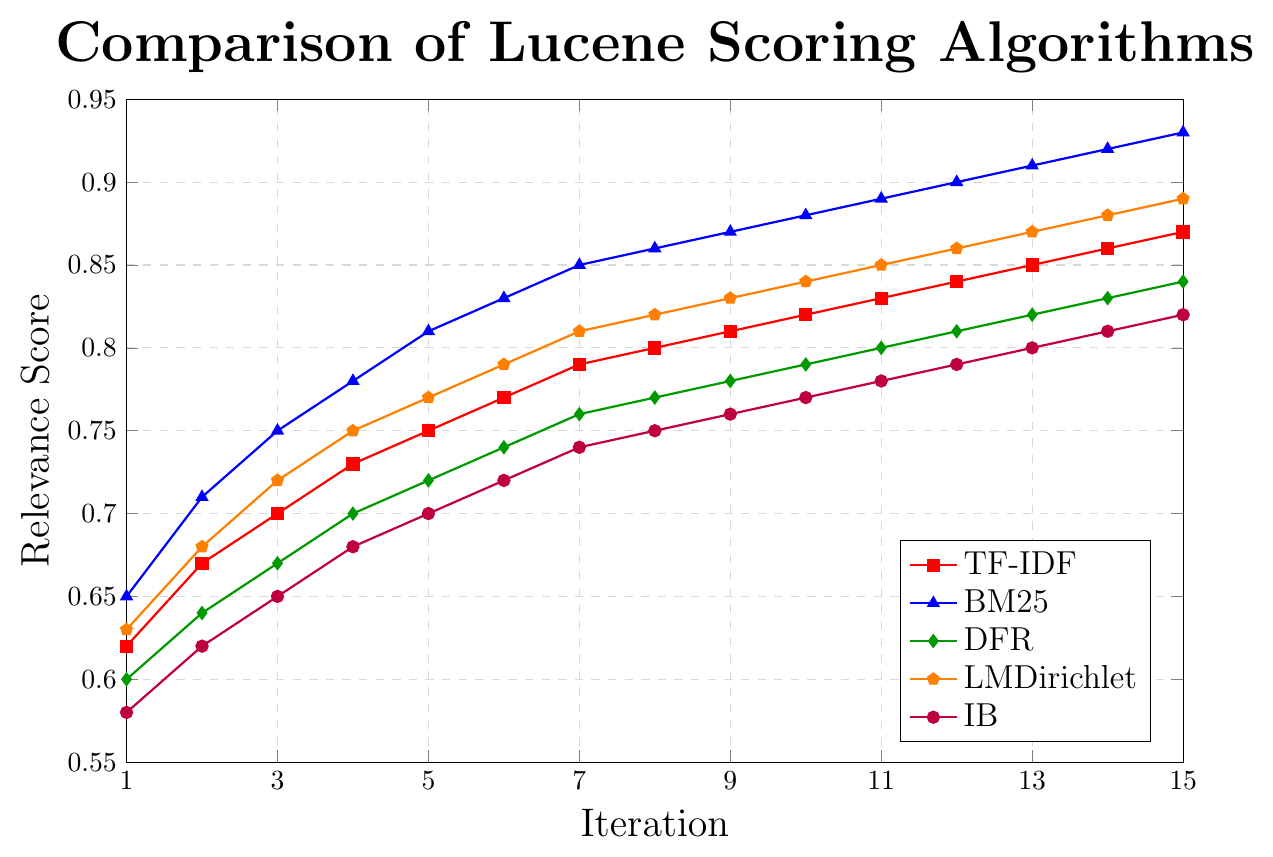Which scoring algorithm has the highest relevance score at iteration 10? To find the highest relevance score at iteration 10, refer to the data points on the line chart for all algorithms. BM25 has a score of 0.88, which is the highest.
Answer: BM25 Which scoring algorithm shows the most significant improvement in relevance score from iteration 1 to iteration 15? Calculate the difference in relevance scores between iteration 1 and iteration 15 for all algorithms. The differences are: TF-IDF (0.87 - 0.62 = 0.25), BM25 (0.93 - 0.65 = 0.28), DFR (0.84 - 0.60 = 0.24), LMDirichlet (0.89 - 0.63 = 0.26), IB (0.82 - 0.58 = 0.24). BM25 shows the most significant improvement with a difference of 0.28.
Answer: BM25 What is the average relevance score of LMDirichlet over all iterations? Add all the relevance scores for LMDirichlet across iterations and divide by the number of iterations: (0.63 + 0.68 + 0.72 + 0.75 + 0.77 + 0.79 + 0.81 + 0.82 + 0.83 + 0.84 + 0.85 + 0.86 + 0.87 + 0.88 + 0.89) / 15. This results in an average score of 0.7973.
Answer: 0.7973 Between TF-IDF and IB, which algorithm has a higher score at iteration 5? Compare the relevance scores of TF-IDF and IB at iteration 5. TF-IDF has a score of 0.75 while IB has a score of 0.70.
Answer: TF-IDF What is the difference in relevance scores between BM25 and DFR at iteration 7? Subtract the relevance score of DFR from that of BM25 at iteration 7: 0.85 - 0.76 = 0.09.
Answer: 0.09 Which scoring algorithm's line is represented in the color red? By examining the legend in the line chart, the color red corresponds to the TF-IDF scoring algorithm.
Answer: TF-IDF What is the cumulative relevance score for DFR over the first five iterations? Sum the relevance scores of DFR for the first five iterations: 0.60 + 0.64 + 0.67 + 0.70 + 0.72 = 3.33.
Answer: 3.33 How much higher is the relevance score for BM25 compared to TF-IDF at iteration 8? Subtract the relevance score of TF-IDF from that of BM25 at iteration 8: 0.86 - 0.80 = 0.06.
Answer: 0.06 Considering the final iteration, which scoring algorithm has the lowest relevance score and what is it? Refer to the data points at iteration 15 and identify the lowest value. IB has the lowest relevance score, which is 0.82.
Answer: IB 0.82 